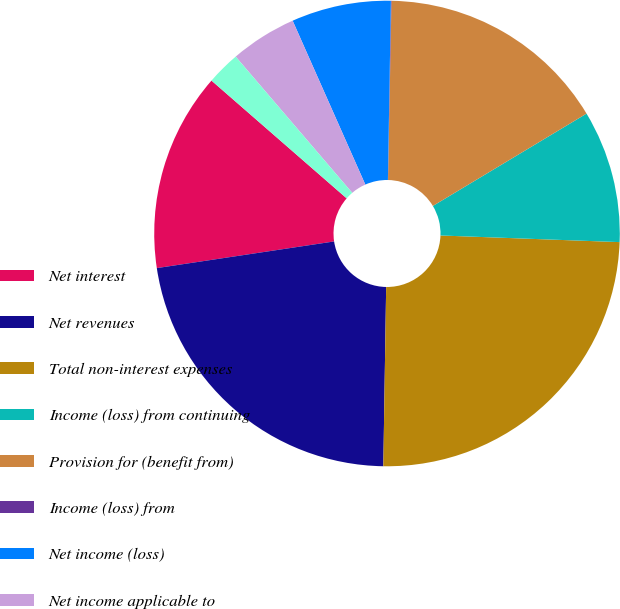Convert chart. <chart><loc_0><loc_0><loc_500><loc_500><pie_chart><fcel>Net interest<fcel>Net revenues<fcel>Total non-interest expenses<fcel>Income (loss) from continuing<fcel>Provision for (benefit from)<fcel>Income (loss) from<fcel>Net income (loss)<fcel>Net income applicable to<fcel>Preferred stock dividends and<nl><fcel>13.78%<fcel>22.37%<fcel>24.66%<fcel>9.2%<fcel>16.08%<fcel>0.04%<fcel>6.91%<fcel>4.62%<fcel>2.33%<nl></chart> 